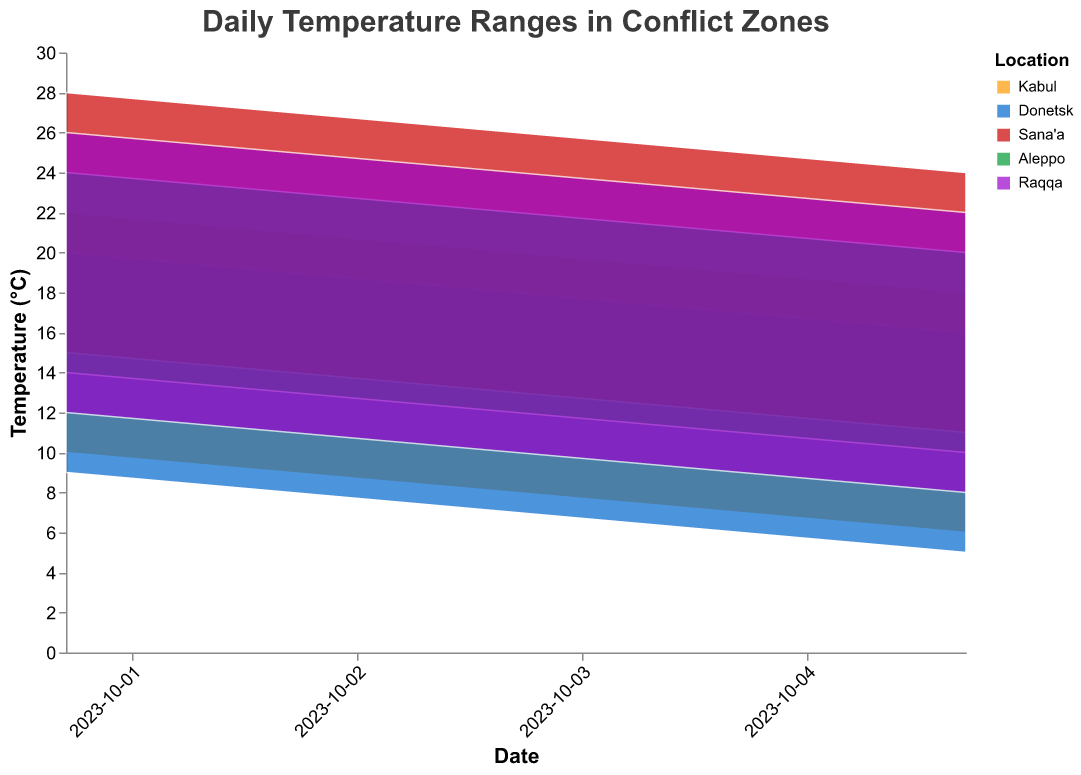What is the title of the chart? The title of the chart is located at the top and reads "Daily Temperature Ranges in Conflict Zones".
Answer: Daily Temperature Ranges in Conflict Zones How many locations are represented in the chart? There are five distinct lines or areas in the chart, each with a unique color representing a location. These are Kabul, Donetsk, Sana'a, Aleppo, and Raqqa.
Answer: 5 Which location has the highest maximum temperature on October 1st? By examining the data points for October 1st, we see that Sana'a has the highest maximum temperature of 28°C.
Answer: Sana'a On October 5th, what is the minimum temperature recorded in Donetsk? By looking at the range shown for the location Donetsk, the minimum temperature for October 5th is 5°C.
Answer: 5°C Which location shows the greatest range in temperatures on October 3rd? By looking at the temperature ranges on October 3rd, Sana'a shows the greatest range with a maximum of 26°C and a minimum of 13°C. The range is 26 - 13 = 13°C.
Answer: Sana'a What trend can be observed in Kabul's temperatures over the five days? Observing Kabul's temperature data across the five days, we see a consistently decreasing trend in both maximum and minimum temperatures. The maximum temperatures decrease from 22°C to 18°C, and the minimum temperatures decrease from 10°C to 6°C.
Answer: Decreasing trend Which location has the smallest temperature range on October 4th? By looking at the ranges on October 4th, we see Aleppo has a maximum of 21°C and a minimum of 11°C, resulting in a range of 21 - 11 = 10°C.
Answer: Aleppo How does the temperature range in Raqqa on October 2nd compare to that in Aleppo on the same day? On October 2nd, Raqqa has a temperature range of 25 - 11 = 14°C, while Aleppo has a range of 23 - 13 = 10°C. Raqqa's range is larger.
Answer: Raqqa has a larger range What is the average maximum temperature in Sana'a over the five days? The maximum temperatures for Sana'a are 28, 27, 26, 25, and 24. Summing these, 28 + 27 + 26 + 25 + 24 = 130, and finding the average, 130 / 5 = 26°C.
Answer: 26°C 